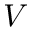<formula> <loc_0><loc_0><loc_500><loc_500>V</formula> 